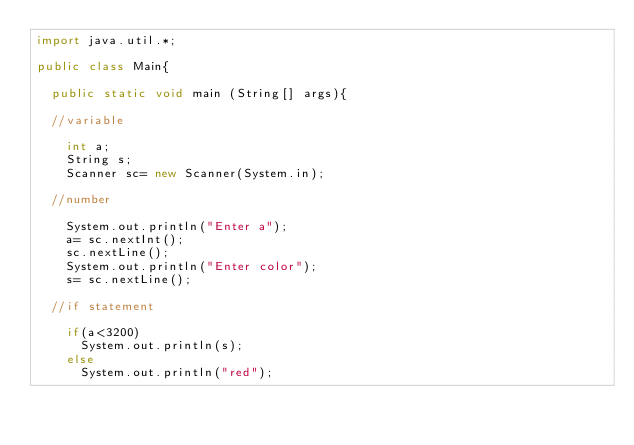Convert code to text. <code><loc_0><loc_0><loc_500><loc_500><_Java_>import java.util.*;

public class Main{

	public static void main (String[] args){

	//variable

		int a;
		String s;
		Scanner sc= new Scanner(System.in);

	//number

		System.out.println("Enter a");
		a= sc.nextInt();
		sc.nextLine();
		System.out.println("Enter color");
		s= sc.nextLine();

	//if statement

		if(a<3200)
			System.out.println(s);
		else
			System.out.println("red");</code> 